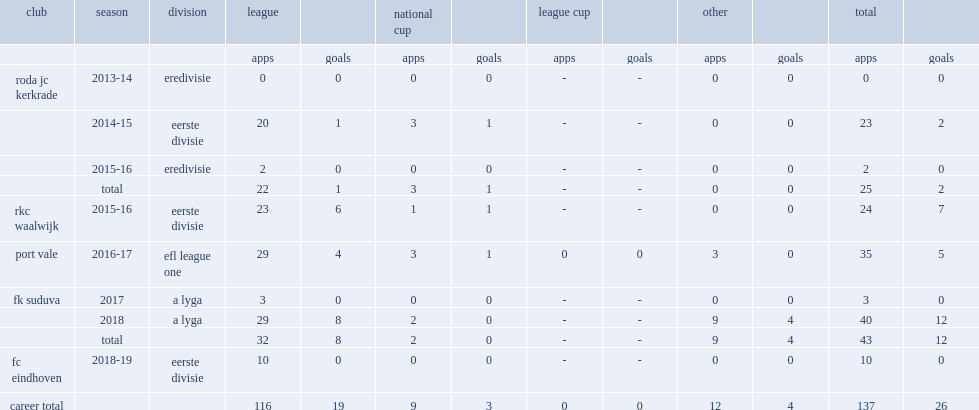Which club did cicilia play for in 2017? Fk suduva. 